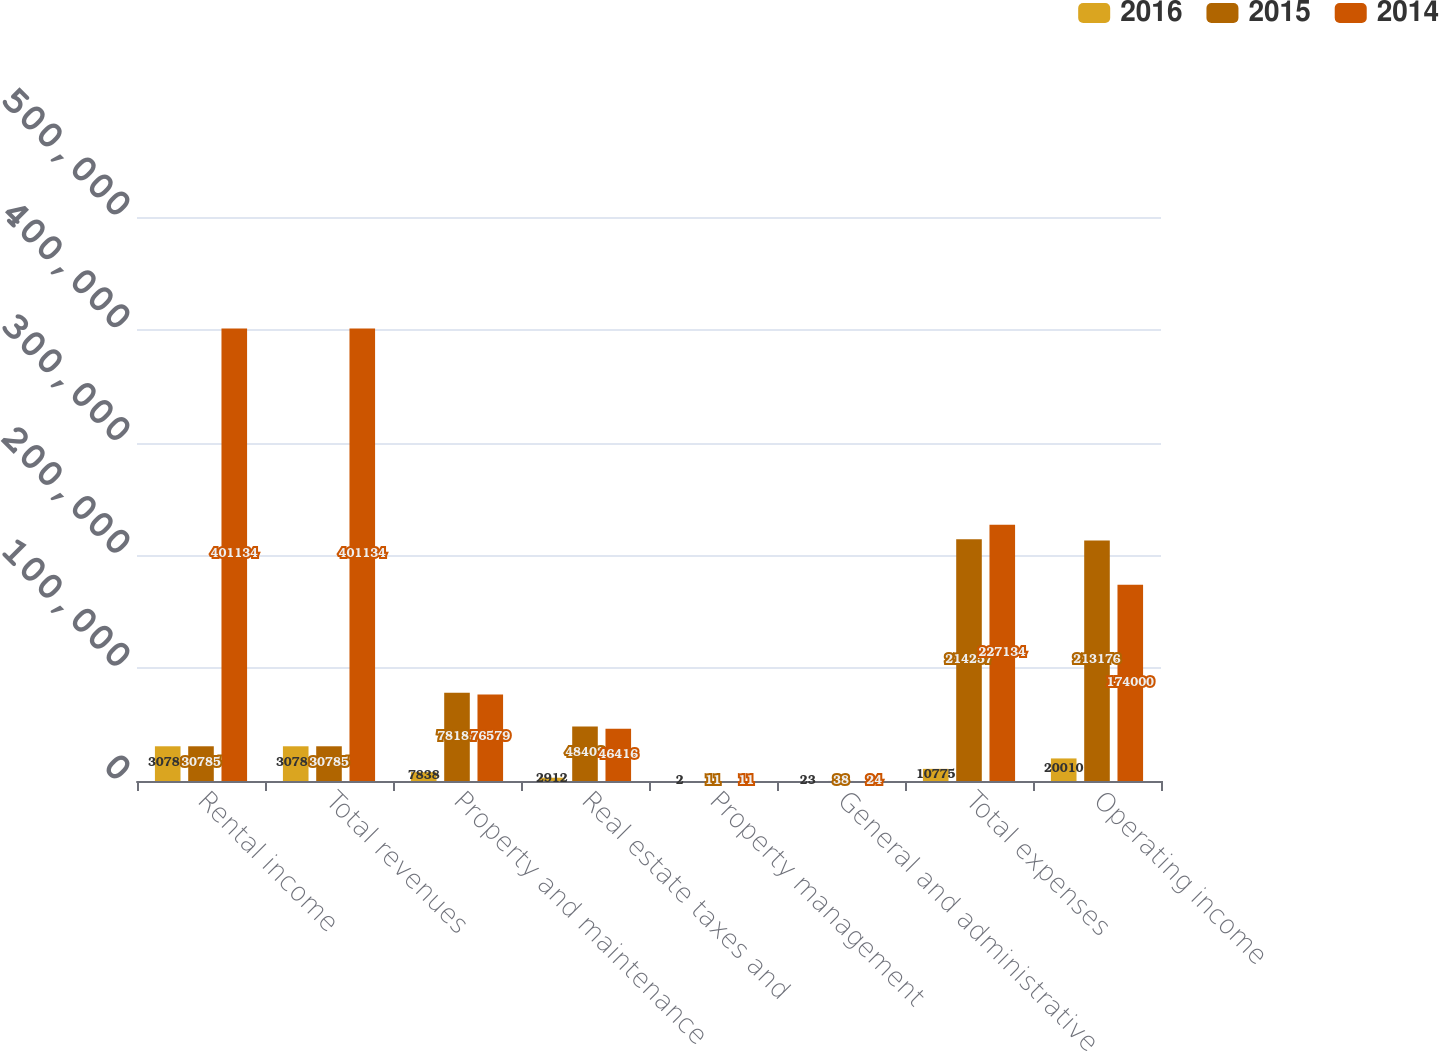Convert chart to OTSL. <chart><loc_0><loc_0><loc_500><loc_500><stacked_bar_chart><ecel><fcel>Rental income<fcel>Total revenues<fcel>Property and maintenance<fcel>Real estate taxes and<fcel>Property management<fcel>General and administrative<fcel>Total expenses<fcel>Operating income<nl><fcel>2016<fcel>30785<fcel>30785<fcel>7838<fcel>2912<fcel>2<fcel>23<fcel>10775<fcel>20010<nl><fcel>2015<fcel>30785<fcel>30785<fcel>78189<fcel>48403<fcel>11<fcel>38<fcel>214257<fcel>213176<nl><fcel>2014<fcel>401134<fcel>401134<fcel>76579<fcel>46416<fcel>11<fcel>24<fcel>227134<fcel>174000<nl></chart> 